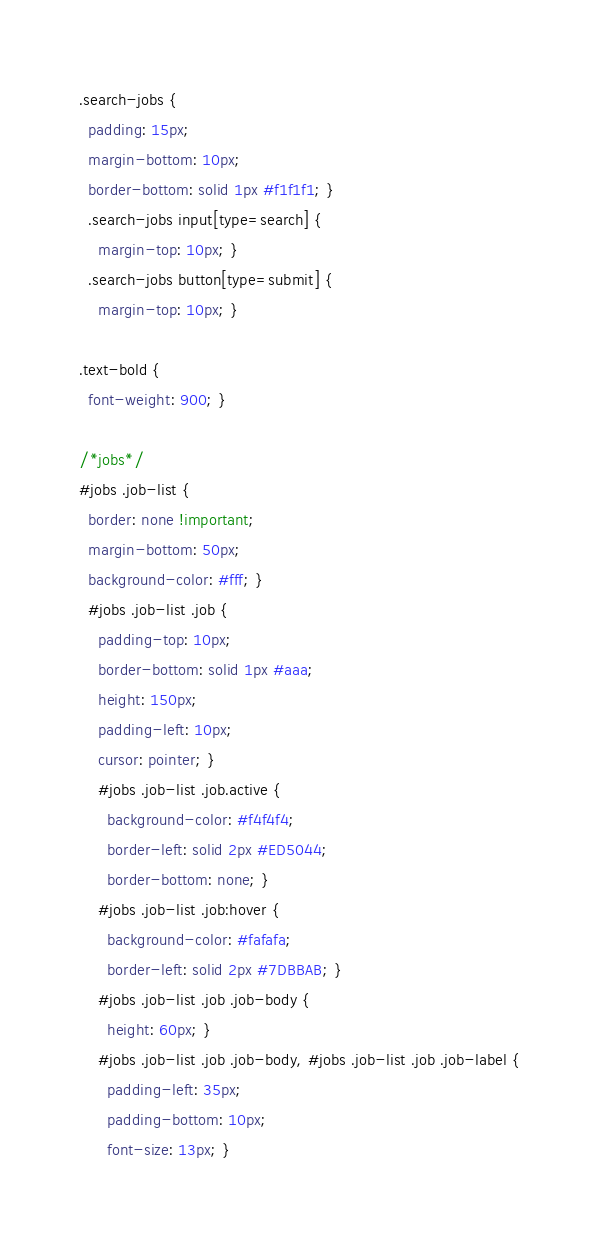<code> <loc_0><loc_0><loc_500><loc_500><_CSS_>.search-jobs {
  padding: 15px;
  margin-bottom: 10px;
  border-bottom: solid 1px #f1f1f1; }
  .search-jobs input[type=search] {
    margin-top: 10px; }
  .search-jobs button[type=submit] {
    margin-top: 10px; }

.text-bold {
  font-weight: 900; }

/*jobs*/
#jobs .job-list {
  border: none !important;
  margin-bottom: 50px;
  background-color: #fff; }
  #jobs .job-list .job {
    padding-top: 10px;
    border-bottom: solid 1px #aaa;
    height: 150px;
    padding-left: 10px;
    cursor: pointer; }
    #jobs .job-list .job.active {
      background-color: #f4f4f4;
      border-left: solid 2px #ED5044;
      border-bottom: none; }
    #jobs .job-list .job:hover {
      background-color: #fafafa;
      border-left: solid 2px #7DBBAB; }
    #jobs .job-list .job .job-body {
      height: 60px; }
    #jobs .job-list .job .job-body, #jobs .job-list .job .job-label {
      padding-left: 35px;
      padding-bottom: 10px;
      font-size: 13px; }</code> 